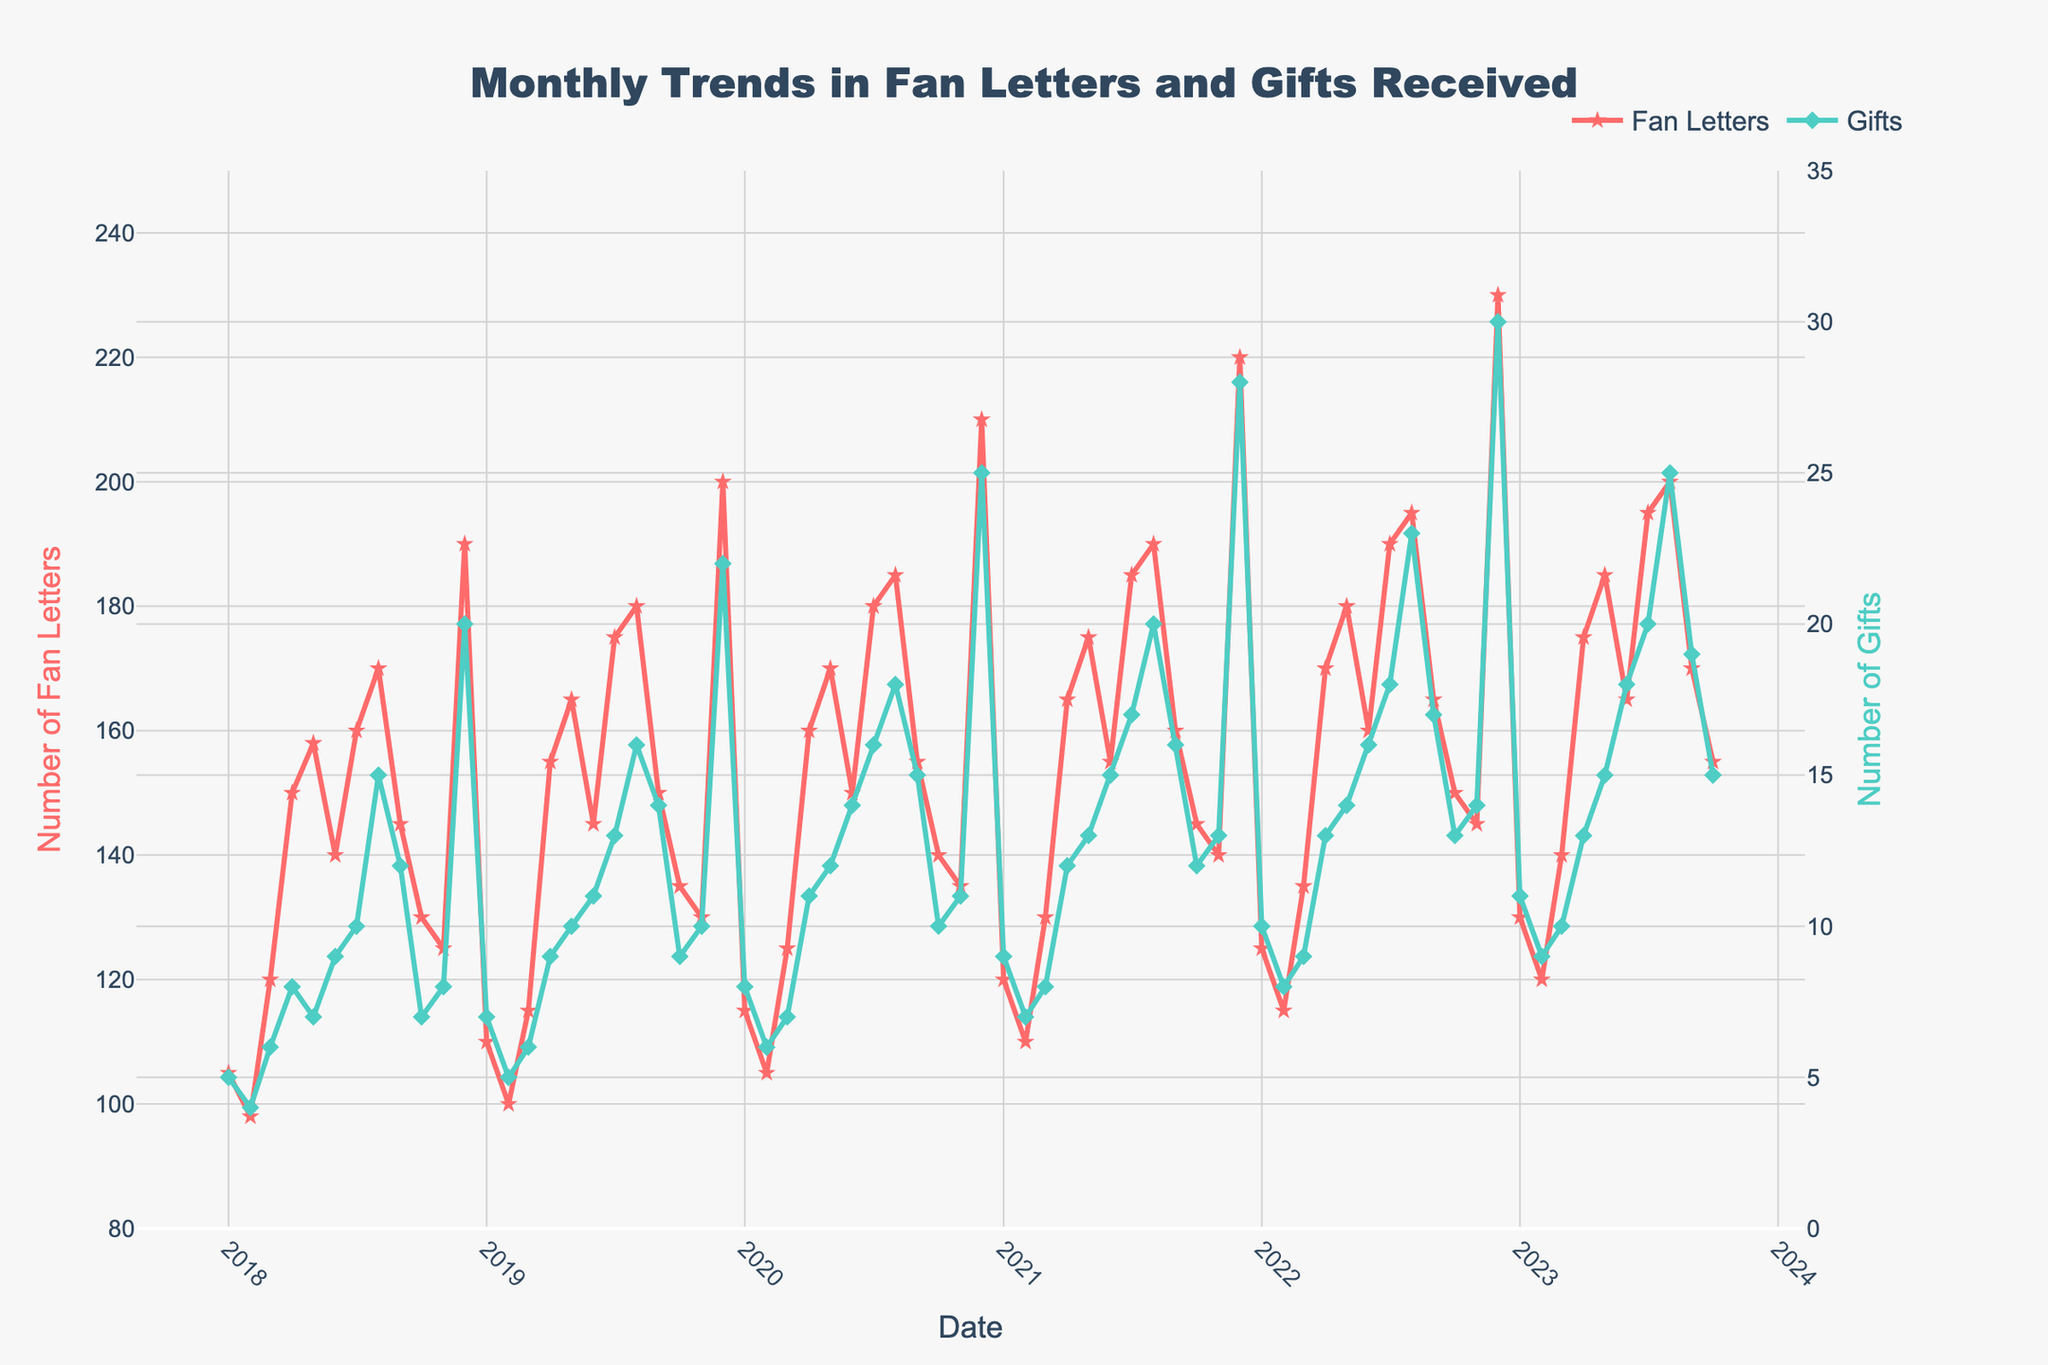What is the title of the figure? The title of the figure is often found at the top center of the chart. It summarizes the main topic of the figure and helps the viewer quickly understand what the data is about. Here, the title given is "Monthly Trends in Fan Letters and Gifts Received."
Answer: Monthly Trends in Fan Letters and Gifts Received What do the y-axes represent? The y-axes are typically labeled to indicate what is being measured. In this figure, the left y-axis represents the "Number of Fan Letters" and the right y-axis represents the "Number of Gifts." This helps in distinguishing the two different data sets.
Answer: Number of Fan Letters and Number of Gifts When did the number of Fan Letters peak and what was the value? By looking at the highest point on the line representing Fan Letters, we see that the peak occurred in December 2022, with the highest value being 230. The value can be read off the y-axis corresponding to that peak.
Answer: December 2022, 230 Compare the numbers of Gifts received in December 2020 and December 2021. Which month had more and by how much? To compare the numbers, we look at the values for Gifts in December 2020 (25) and December 2021 (28). By subtracting the former from the latter, we find that December 2021 had 28 - 25 = 3 more Gifts than December 2020.
Answer: December 2021, by 3 What is the trend in the number of Fan Letters from January 2018 to December 2019? By observing the line representing Fan Letters from January 2018 to December 2019, we can see an overall increasing trend peaking at 200 in December 2019, after starting at 105 in January 2018.
Answer: Increasing trend Is there a seasonal pattern in the number of Gifts received every year? By examining the data points for Gifts over each year, we can observe a recurring peak in December. This indicates that there is a seasonal pattern, with the number of Gifts increasing towards the end of the year.
Answer: Yes What is the average number of Fan Letters received in 2022? To compute the average for 2022, we sum the values for each month in 2022: 125 + 115 + 135 + 170 + 180 + 160 + 190 + 195 + 165 + 150 + 145 + 230 = 1970. Then divide by 12 months: 1970 / 12 ≈ 164.2.
Answer: 164.2 How does the number of Fan Letters in January 2023 compare to that in January 2018? By comparing the values for January 2023 (130) and January 2018 (105), we see that the number of Fan Letters in January 2023 is higher. The increase can be computed as 130 - 105 = 25.
Answer: January 2023 is higher by 25 What is the difference between the maximum number of Gifts and the minimum number of Gifts received over the entire period? Looking at the Gifts data, the maximum value is 30 (December 2022) and the minimum is 4 (February 2018), so the difference is 30 - 4 = 26.
Answer: 26 